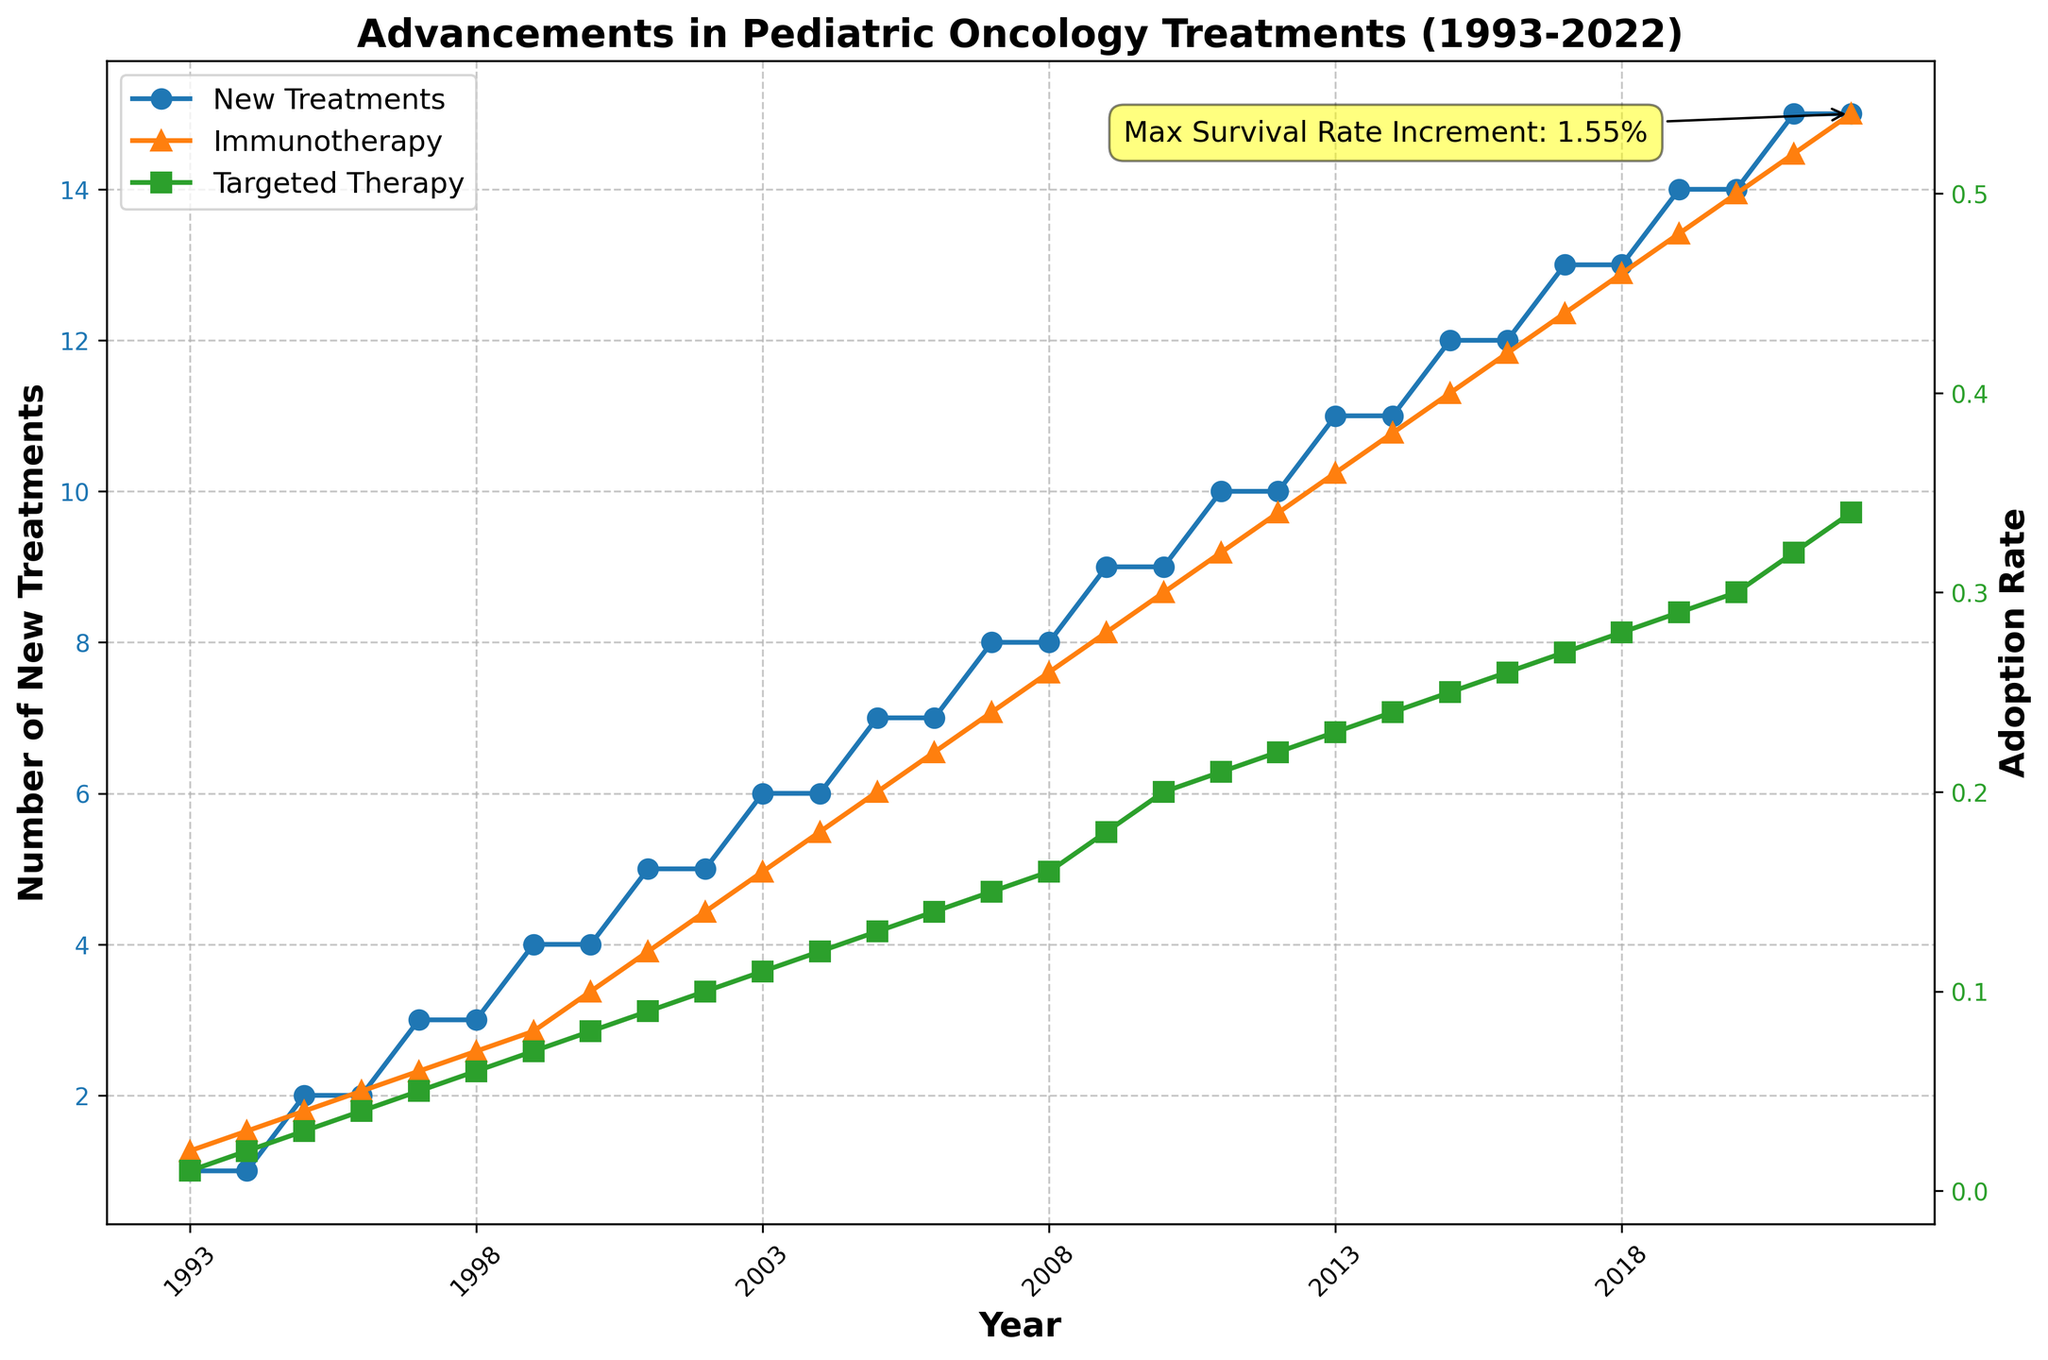What is the title of the figure? The title is prominently placed at the top of the figure. To determine the title, look for the bolded text at the top center of the plot.
Answer: Advancements in Pediatric Oncology Treatments (1993-2022) What does the left y-axis represent? The left y-axis typically has a description or label next to it to indicate what it measures. In this figure, it indicates "Number of New Treatments."
Answer: Number of New Treatments Which year saw the highest number of new treatments adopted? By analyzing the plot of "New Treatments Adopted" over the years, you can identify the peak point. The highest value reaches 15 in the year 2022.
Answer: 2022 What is the adoption rate of immunotherapy in 2015? Locate the year 2015 on the x-axis and trace it upward to intersect with the "Immunotherapy Adoption Rate" line, represented by upward-pointing triangles. The corresponding y-axis value for 2015 is 0.4.
Answer: 0.4 How did the adoption rates of targeted therapy and immunotherapy compare in 2007? Trace the year 2007 upward along the x-axis and note where it intersects with both the "Targeted Therapy Adoption Rate" (squares) and "Immunotherapy Adoption Rate" (triangles). Immunotherapy is at 0.24, and targeted therapy is at 0.15, indicating immunotherapy had a higher adoption rate.
Answer: Immunotherapy had a higher rate at 0.24; Targeted Therapy was 0.15 What was the increment in the survival rate in 2013? The survival rate increment each year is often presented as annotations or data points. Analyzing the plot or looking for specific annotations can provide the exact value. In 2013, the increment was 1.1%.
Answer: 1.1% How did the number of new treatments adopted change between 1993 and 2022? By comparing the initial value in 1993 with the final value in 2022 on the line representing "New Treatments Adopted," you can calculate the change. It increased from 1 in 1993 to 15 in 2022.
Answer: Increased by 14 Which adoption rate has consistently been higher, immunotherapy or targeted therapy? By scanning the plot lines over the range of years, the orange triangles (immunotherapy) consistently have higher y-axis values than the green squares (targeted therapy).
Answer: Immunotherapy What is the annotation on the figure highlighting? Annotations are added to emphasize significant points. This annotation highlights the maximum survival rate increment, which is 1.55% in 2022, and is visually connected to the end of the "New Treatments Adopted" line.
Answer: Max Survival Rate Increment: 1.55% What trend can be observed in the chemotherapy enhancements over the years? Although chemotherapy enhancements are not visually plotted, the annotation text indicates a steady increase over the years. This can be typically inferred from related trends such as survival rate increments and adoption rates of therapies.
Answer: Steady increase 